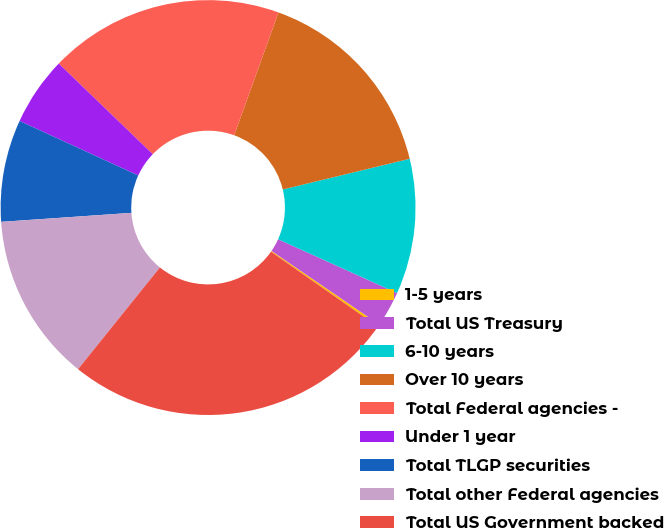<chart> <loc_0><loc_0><loc_500><loc_500><pie_chart><fcel>1-5 years<fcel>Total US Treasury<fcel>6-10 years<fcel>Over 10 years<fcel>Total Federal agencies -<fcel>Under 1 year<fcel>Total TLGP securities<fcel>Total other Federal agencies<fcel>Total US Government backed<nl><fcel>0.19%<fcel>2.78%<fcel>10.54%<fcel>15.71%<fcel>18.3%<fcel>5.36%<fcel>7.95%<fcel>13.12%<fcel>26.05%<nl></chart> 